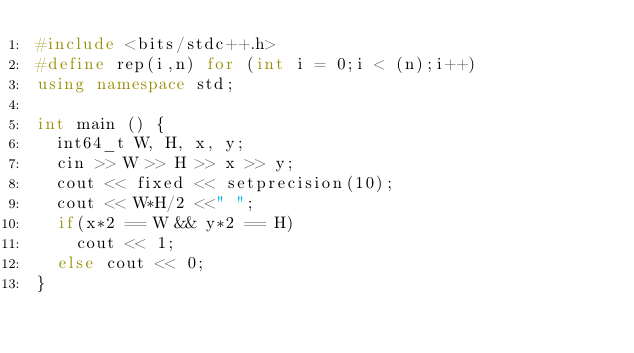<code> <loc_0><loc_0><loc_500><loc_500><_C++_>#include <bits/stdc++.h>
#define rep(i,n) for (int i = 0;i < (n);i++)
using namespace std;

int main () {
  int64_t W, H, x, y;
  cin >> W >> H >> x >> y;
  cout << fixed << setprecision(10);
  cout << W*H/2 <<" ";
  if(x*2 == W && y*2 == H)
    cout << 1;
  else cout << 0;
}</code> 